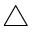Convert formula to latex. <formula><loc_0><loc_0><loc_500><loc_500>\bigtriangleup</formula> 